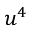Convert formula to latex. <formula><loc_0><loc_0><loc_500><loc_500>u ^ { 4 }</formula> 